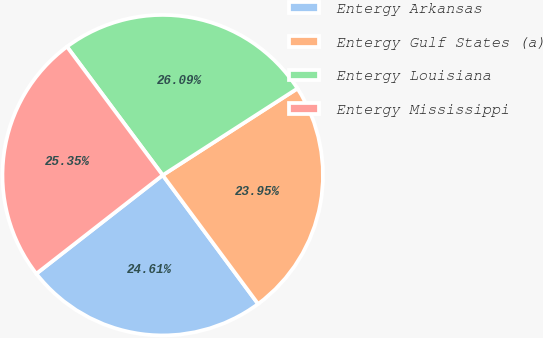<chart> <loc_0><loc_0><loc_500><loc_500><pie_chart><fcel>Entergy Arkansas<fcel>Entergy Gulf States (a)<fcel>Entergy Louisiana<fcel>Entergy Mississippi<nl><fcel>24.61%<fcel>23.95%<fcel>26.09%<fcel>25.35%<nl></chart> 